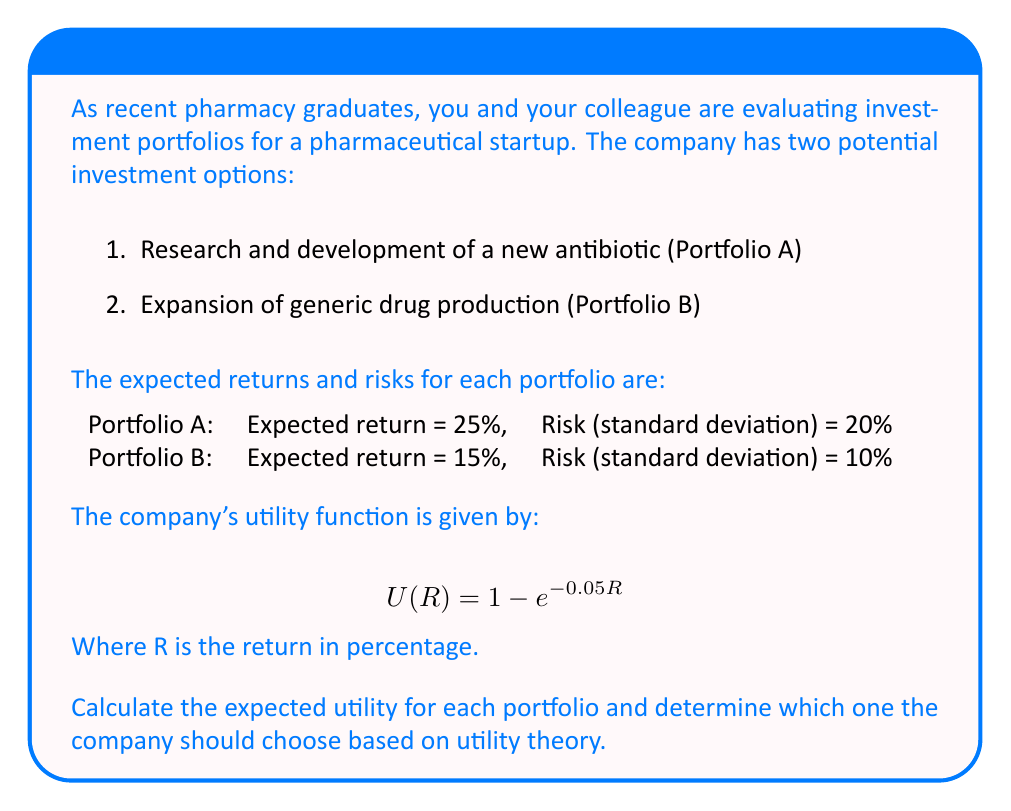Solve this math problem. To solve this problem, we'll follow these steps:

1. Calculate the expected utility for each portfolio
2. Compare the expected utilities
3. Make a decision based on the higher expected utility

Step 1: Calculate the expected utility for each portfolio

For Portfolio A:
Expected return (R_A) = 25%
Risk (σ_A) = 20%

The expected utility is:
$$E[U(R_A)] = E[1 - e^{-0.05R_A}]$$

Using the moment-generating function of a normal distribution:
$$E[e^{-0.05R_A}] = e^{-0.05\mu_A + \frac{1}{2}(0.05^2)\sigma_A^2}$$

Where μ_A = 25 and σ_A = 20

$$E[e^{-0.05R_A}] = e^{-0.05(25) + \frac{1}{2}(0.05^2)(20^2)} = e^{-1.25 + 0.25} = e^{-1}$$

Therefore,
$$E[U(R_A)] = 1 - e^{-1} \approx 0.6321$$

For Portfolio B:
Expected return (R_B) = 15%
Risk (σ_B) = 10%

Following the same process:
$$E[U(R_B)] = 1 - e^{-0.05\mu_B + \frac{1}{2}(0.05^2)\sigma_B^2}$$
$$E[U(R_B)] = 1 - e^{-0.05(15) + \frac{1}{2}(0.05^2)(10^2)}$$
$$E[U(R_B)] = 1 - e^{-0.75 + 0.0625} = 1 - e^{-0.6875} \approx 0.4972$$

Step 2: Compare the expected utilities

E[U(R_A)] ≈ 0.6321
E[U(R_B)] ≈ 0.4972

Step 3: Make a decision

Since E[U(R_A)] > E[U(R_B)], the company should choose Portfolio A (Research and development of a new antibiotic) based on utility theory.
Answer: Choose Portfolio A (Expected utility: 0.6321) 